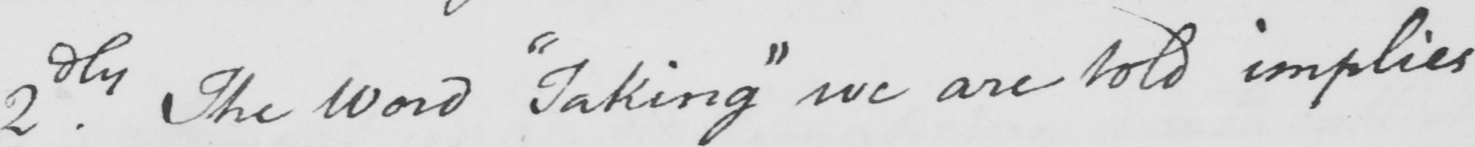Please provide the text content of this handwritten line. 2.dly The word  " taking "  we are told implies 